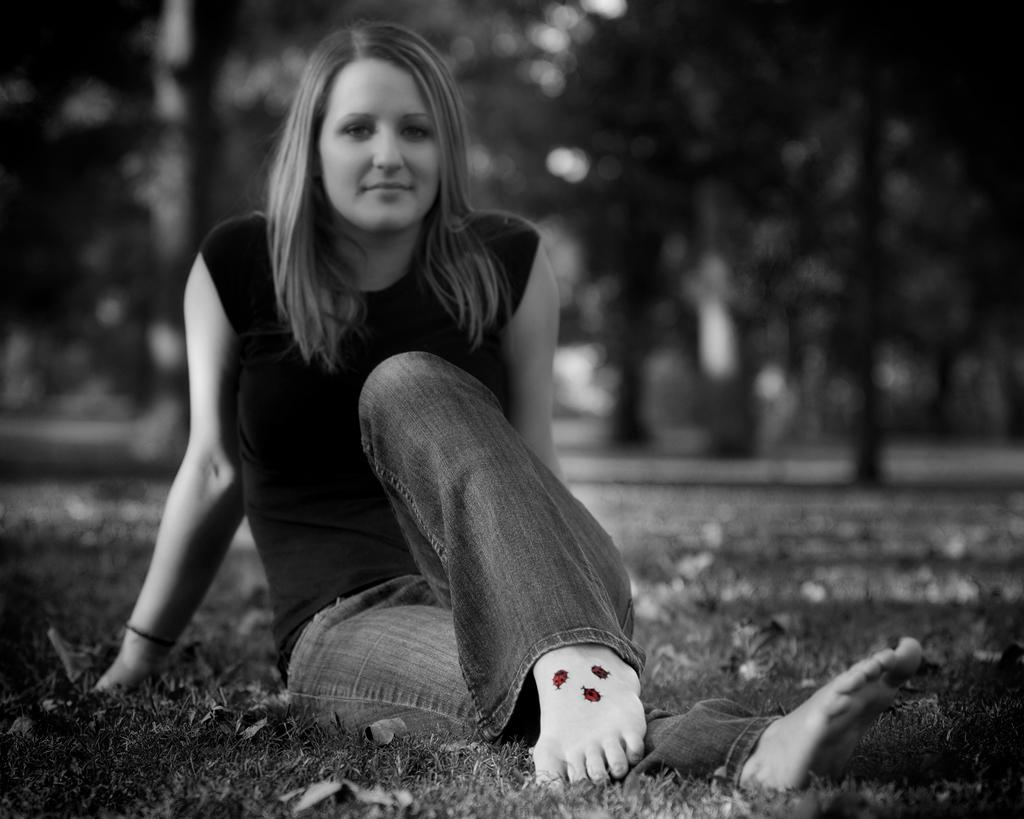Who is present in the image? There is a woman in the image. What is the woman doing in the image? The woman is sitting on the ground. What is the ground covered with? The ground is covered in greenery. What type of tattoos does the woman have on her leg? The woman has insect tattoos on her leg. What can be seen in the background of the image? There are trees in the background of the image. What type of dinosaur is visible in the image? There are no dinosaurs present in the image. How much pain is the woman experiencing in the image? There is no indication of pain in the image, so it cannot be determined. 